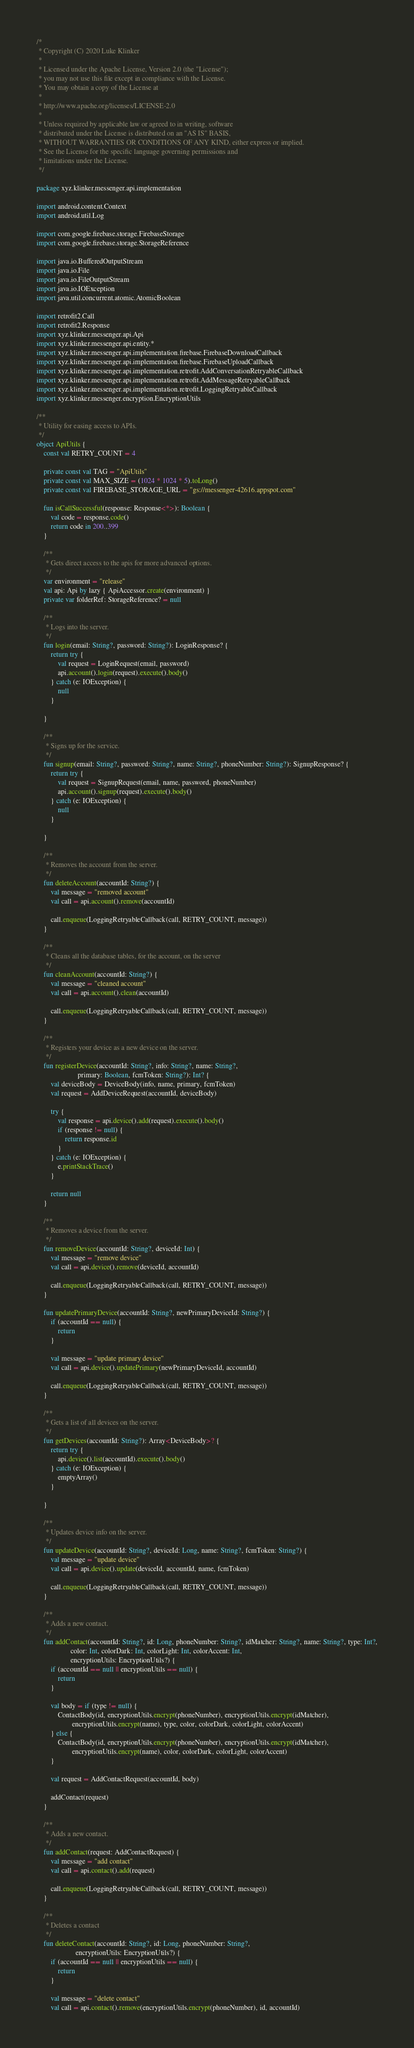<code> <loc_0><loc_0><loc_500><loc_500><_Kotlin_>/*
 * Copyright (C) 2020 Luke Klinker
 *
 * Licensed under the Apache License, Version 2.0 (the "License");
 * you may not use this file except in compliance with the License.
 * You may obtain a copy of the License at
 *
 * http://www.apache.org/licenses/LICENSE-2.0
 *
 * Unless required by applicable law or agreed to in writing, software
 * distributed under the License is distributed on an "AS IS" BASIS,
 * WITHOUT WARRANTIES OR CONDITIONS OF ANY KIND, either express or implied.
 * See the License for the specific language governing permissions and
 * limitations under the License.
 */

package xyz.klinker.messenger.api.implementation

import android.content.Context
import android.util.Log

import com.google.firebase.storage.FirebaseStorage
import com.google.firebase.storage.StorageReference

import java.io.BufferedOutputStream
import java.io.File
import java.io.FileOutputStream
import java.io.IOException
import java.util.concurrent.atomic.AtomicBoolean

import retrofit2.Call
import retrofit2.Response
import xyz.klinker.messenger.api.Api
import xyz.klinker.messenger.api.entity.*
import xyz.klinker.messenger.api.implementation.firebase.FirebaseDownloadCallback
import xyz.klinker.messenger.api.implementation.firebase.FirebaseUploadCallback
import xyz.klinker.messenger.api.implementation.retrofit.AddConversationRetryableCallback
import xyz.klinker.messenger.api.implementation.retrofit.AddMessageRetryableCallback
import xyz.klinker.messenger.api.implementation.retrofit.LoggingRetryableCallback
import xyz.klinker.messenger.encryption.EncryptionUtils

/**
 * Utility for easing access to APIs.
 */
object ApiUtils {
    const val RETRY_COUNT = 4

    private const val TAG = "ApiUtils"
    private const val MAX_SIZE = (1024 * 1024 * 5).toLong()
    private const val FIREBASE_STORAGE_URL = "gs://messenger-42616.appspot.com"

    fun isCallSuccessful(response: Response<*>): Boolean {
        val code = response.code()
        return code in 200..399
    }

    /**
     * Gets direct access to the apis for more advanced options.
     */
    var environment = "release"
    val api: Api by lazy { ApiAccessor.create(environment) }
    private var folderRef: StorageReference? = null

    /**
     * Logs into the server.
     */
    fun login(email: String?, password: String?): LoginResponse? {
        return try {
            val request = LoginRequest(email, password)
            api.account().login(request).execute().body()
        } catch (e: IOException) {
            null
        }

    }

    /**
     * Signs up for the service.
     */
    fun signup(email: String?, password: String?, name: String?, phoneNumber: String?): SignupResponse? {
        return try {
            val request = SignupRequest(email, name, password, phoneNumber)
            api.account().signup(request).execute().body()
        } catch (e: IOException) {
            null
        }

    }

    /**
     * Removes the account from the server.
     */
    fun deleteAccount(accountId: String?) {
        val message = "removed account"
        val call = api.account().remove(accountId)

        call.enqueue(LoggingRetryableCallback(call, RETRY_COUNT, message))
    }

    /**
     * Cleans all the database tables, for the account, on the server
     */
    fun cleanAccount(accountId: String?) {
        val message = "cleaned account"
        val call = api.account().clean(accountId)

        call.enqueue(LoggingRetryableCallback(call, RETRY_COUNT, message))
    }

    /**
     * Registers your device as a new device on the server.
     */
    fun registerDevice(accountId: String?, info: String?, name: String?,
                       primary: Boolean, fcmToken: String?): Int? {
        val deviceBody = DeviceBody(info, name, primary, fcmToken)
        val request = AddDeviceRequest(accountId, deviceBody)

        try {
            val response = api.device().add(request).execute().body()
            if (response != null) {
                return response.id
            }
        } catch (e: IOException) {
            e.printStackTrace()
        }

        return null
    }

    /**
     * Removes a device from the server.
     */
    fun removeDevice(accountId: String?, deviceId: Int) {
        val message = "remove device"
        val call = api.device().remove(deviceId, accountId)

        call.enqueue(LoggingRetryableCallback(call, RETRY_COUNT, message))
    }

    fun updatePrimaryDevice(accountId: String?, newPrimaryDeviceId: String?) {
        if (accountId == null) {
            return
        }

        val message = "update primary device"
        val call = api.device().updatePrimary(newPrimaryDeviceId, accountId)

        call.enqueue(LoggingRetryableCallback(call, RETRY_COUNT, message))
    }

    /**
     * Gets a list of all devices on the server.
     */
    fun getDevices(accountId: String?): Array<DeviceBody>? {
        return try {
            api.device().list(accountId).execute().body()
        } catch (e: IOException) {
            emptyArray()
        }

    }

    /**
     * Updates device info on the server.
     */
    fun updateDevice(accountId: String?, deviceId: Long, name: String?, fcmToken: String?) {
        val message = "update device"
        val call = api.device().update(deviceId, accountId, name, fcmToken)

        call.enqueue(LoggingRetryableCallback(call, RETRY_COUNT, message))
    }

    /**
     * Adds a new contact.
     */
    fun addContact(accountId: String?, id: Long, phoneNumber: String?, idMatcher: String?, name: String?, type: Int?,
                   color: Int, colorDark: Int, colorLight: Int, colorAccent: Int,
                   encryptionUtils: EncryptionUtils?) {
        if (accountId == null || encryptionUtils == null) {
            return
        }

        val body = if (type != null) {
            ContactBody(id, encryptionUtils.encrypt(phoneNumber), encryptionUtils.encrypt(idMatcher),
                    encryptionUtils.encrypt(name), type, color, colorDark, colorLight, colorAccent)
        } else {
            ContactBody(id, encryptionUtils.encrypt(phoneNumber), encryptionUtils.encrypt(idMatcher),
                    encryptionUtils.encrypt(name), color, colorDark, colorLight, colorAccent)
        }

        val request = AddContactRequest(accountId, body)

        addContact(request)
    }

    /**
     * Adds a new contact.
     */
    fun addContact(request: AddContactRequest) {
        val message = "add contact"
        val call = api.contact().add(request)

        call.enqueue(LoggingRetryableCallback(call, RETRY_COUNT, message))
    }

    /**
     * Deletes a contact
     */
    fun deleteContact(accountId: String?, id: Long, phoneNumber: String?,
                      encryptionUtils: EncryptionUtils?) {
        if (accountId == null || encryptionUtils == null) {
            return
        }

        val message = "delete contact"
        val call = api.contact().remove(encryptionUtils.encrypt(phoneNumber), id, accountId)
</code> 